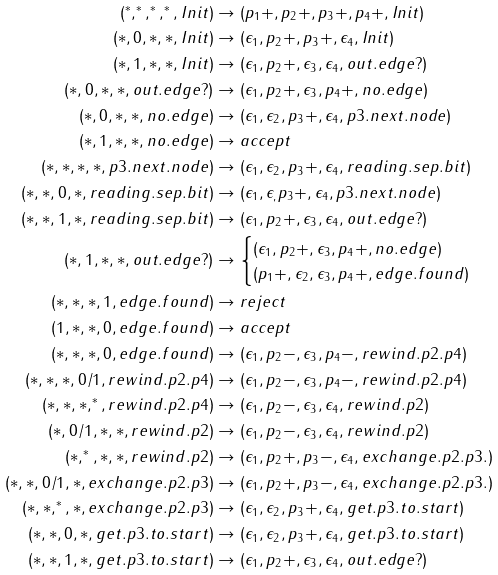Convert formula to latex. <formula><loc_0><loc_0><loc_500><loc_500>( ^ { * } , ^ { * } , ^ { * } , ^ { * } , I n i t ) & \rightarrow ( p _ { 1 } + , p _ { 2 } + , p _ { 3 } + , p _ { 4 } + , I n i t ) \\ ( * , 0 , * , * , I n i t ) & \rightarrow ( \epsilon _ { 1 } , p _ { 2 } + , p _ { 3 } + , \epsilon _ { 4 } , I n i t ) \\ ( * , 1 , * , * , I n i t ) & \rightarrow ( \epsilon _ { 1 } , p _ { 2 } + , \epsilon _ { 3 } , \epsilon _ { 4 } , o u t . e d g e ? ) \\ ( * , 0 , * , * , o u t . e d g e ? ) & \rightarrow ( \epsilon _ { 1 } , p _ { 2 } + , \epsilon _ { 3 } , p _ { 4 } + , n o . e d g e ) \\ ( * , 0 , * , * , n o . e d g e ) & \rightarrow ( \epsilon _ { 1 } , \epsilon _ { 2 } , p _ { 3 } + , \epsilon _ { 4 } , p 3 . n e x t . n o d e ) \\ ( * , 1 , * , * , n o . e d g e ) & \rightarrow a c c e p t \\ ( * , * , * , * , p 3 . n e x t . n o d e ) & \rightarrow ( \epsilon _ { 1 } , \epsilon _ { 2 } , p _ { 3 } + , \epsilon _ { 4 } , r e a d i n g . s e p . b i t ) \\ ( * , * , 0 , * , r e a d i n g . s e p . b i t ) & \rightarrow ( \epsilon _ { 1 } , \epsilon _ { , } p _ { 3 } + , \epsilon _ { 4 } , p 3 . n e x t . n o d e ) \\ ( * , * , 1 , * , r e a d i n g . s e p . b i t ) & \rightarrow ( \epsilon _ { 1 } , p _ { 2 } + , \epsilon _ { 3 } , \epsilon _ { 4 } , o u t . e d g e ? ) \\ ( * , 1 , * , * , o u t . e d g e ? ) & \rightarrow \begin{cases} ( \epsilon _ { 1 } , p _ { 2 } + , \epsilon _ { 3 } , p _ { 4 } + , n o . e d g e ) \\ ( p _ { 1 } + , \epsilon _ { 2 } , \epsilon _ { 3 } , p _ { 4 } + , e d g e . f o u n d ) \end{cases} \\ ( * , * , * , 1 , e d g e . f o u n d ) & \rightarrow r e j e c t \\ ( 1 , * , * , 0 , e d g e . f o u n d ) & \rightarrow a c c e p t \\ ( * , * , * , 0 , e d g e . f o u n d ) & \rightarrow ( \epsilon _ { 1 } , p _ { 2 } - , \epsilon _ { 3 } , p _ { 4 } - , r e w i n d . p 2 . p 4 ) \\ ( * , * , * , 0 / 1 , r e w i n d . p 2 . p 4 ) & \rightarrow ( \epsilon _ { 1 } , p _ { 2 } - , \epsilon _ { 3 } , p _ { 4 } - , r e w i n d . p 2 . p 4 ) \\ ( * , * , * , ^ { * } , r e w i n d . p 2 . p 4 ) & \rightarrow ( \epsilon _ { 1 } , p _ { 2 } - , \epsilon _ { 3 } , \epsilon _ { 4 } , r e w i n d . p 2 ) \\ ( * , 0 / 1 , * , * , r e w i n d . p 2 ) & \rightarrow ( \epsilon _ { 1 } , p _ { 2 } - , \epsilon _ { 3 } , \epsilon _ { 4 } , r e w i n d . p 2 ) \\ ( * , ^ { * } , * , * , r e w i n d . p 2 ) & \rightarrow ( \epsilon _ { 1 } , p _ { 2 } + , p _ { 3 } - , \epsilon _ { 4 } , e x c h a n g e . p 2 . p 3 . ) \\ ( * , * , 0 / 1 , * , e x c h a n g e . p 2 . p 3 ) & \rightarrow ( \epsilon _ { 1 } , p _ { 2 } + , p _ { 3 } - , \epsilon _ { 4 } , e x c h a n g e . p 2 . p 3 . ) \\ ( * , * , ^ { * } , * , e x c h a n g e . p 2 . p 3 ) & \rightarrow ( \epsilon _ { 1 } , \epsilon _ { 2 } , p _ { 3 } + , \epsilon _ { 4 } , g e t . p 3 . t o . s t a r t ) \\ ( * , * , 0 , * , g e t . p 3 . t o . s t a r t ) & \rightarrow ( \epsilon _ { 1 } , \epsilon _ { 2 } , p _ { 3 } + , \epsilon _ { 4 } , g e t . p 3 . t o . s t a r t ) \\ ( * , * , 1 , * , g e t . p 3 . t o . s t a r t ) & \rightarrow ( \epsilon _ { 1 } , p _ { 2 } + , \epsilon _ { 3 } , \epsilon _ { 4 } , o u t . e d g e ? )</formula> 